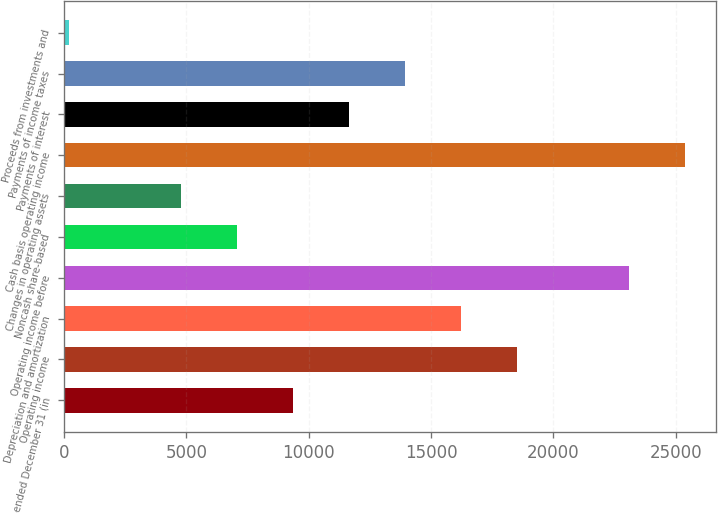<chart> <loc_0><loc_0><loc_500><loc_500><bar_chart><fcel>Year ended December 31 (in<fcel>Operating income<fcel>Depreciation and amortization<fcel>Operating income before<fcel>Noncash share-based<fcel>Changes in operating assets<fcel>Cash basis operating income<fcel>Payments of interest<fcel>Payments of income taxes<fcel>Proceeds from investments and<nl><fcel>9345.6<fcel>18501.2<fcel>16212.3<fcel>23079<fcel>7056.7<fcel>4767.8<fcel>25367.9<fcel>11634.5<fcel>13923.4<fcel>190<nl></chart> 